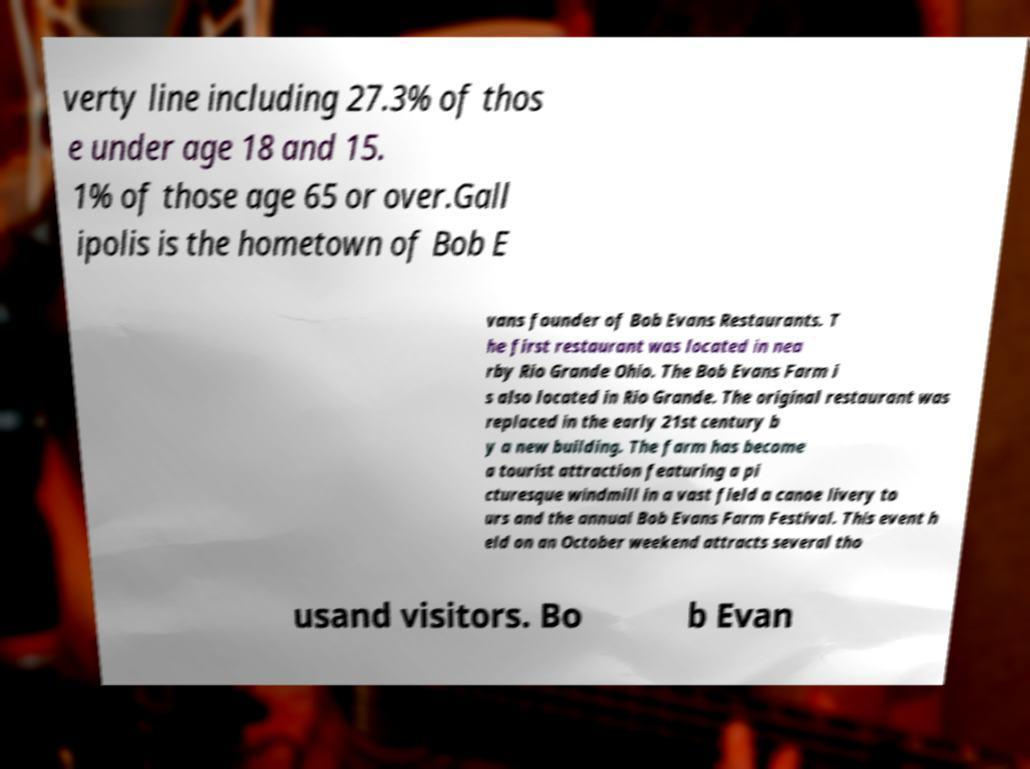I need the written content from this picture converted into text. Can you do that? verty line including 27.3% of thos e under age 18 and 15. 1% of those age 65 or over.Gall ipolis is the hometown of Bob E vans founder of Bob Evans Restaurants. T he first restaurant was located in nea rby Rio Grande Ohio. The Bob Evans Farm i s also located in Rio Grande. The original restaurant was replaced in the early 21st century b y a new building. The farm has become a tourist attraction featuring a pi cturesque windmill in a vast field a canoe livery to urs and the annual Bob Evans Farm Festival. This event h eld on an October weekend attracts several tho usand visitors. Bo b Evan 